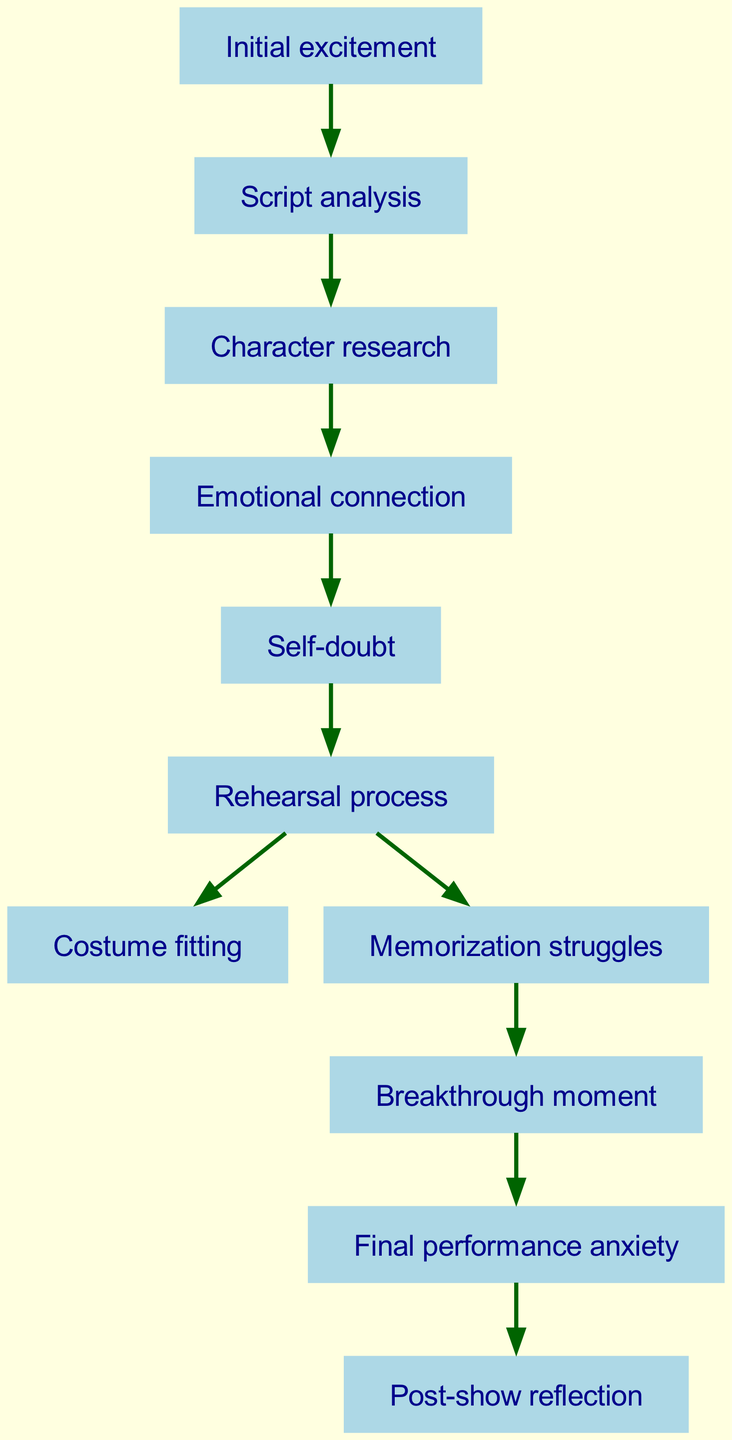What is the first step in the emotional journey? The diagram indicates that "Initial excitement" is the starting point, representing the first emotion before any preparation steps occur.
Answer: Initial excitement How many nodes are there in total? By counting the entries under the 'nodes' section in the data, a total of eleven distinct stages in the emotional journey can be identified.
Answer: 11 Which stage follows "Emotional connection"? The directed flow shows that "Self-doubt" directly follows "Emotional connection," indicating the next emotional stage after forming a connection to the character.
Answer: Self-doubt What connects "Memorization struggles" to "Breakthrough moment"? The diagram demonstrates that there is a directional edge leading from "Memorization struggles" to "Breakthrough moment," indicating that overcoming memorization issues leads to a key inspirational realization.
Answer: Breakthrough moment What is the last stage in the journey? The diagram shows that the final node in the sequence is "Post-show reflection," which concludes the emotional journey of the actor after the performance has been completed.
Answer: Post-show reflection Which node is reached after "Rehearsal process"? "Costume fitting" and "Memorization struggles" are both subsequent to "Rehearsal process," representing two parallel paths the actor can experience following rehearsals.
Answer: Costume fitting, Memorization struggles What is the emotional state reached before "Final performance anxiety"? According to the directed graph, the "Breakthrough moment" serves as the penultimate state before the actor experiences "Final performance anxiety," marking a pivotal point in preparation.
Answer: Breakthrough moment How many edges in total connect the nodes? By analyzing the 'edges' section, it's evident that there are ten distinct connections or relationships between the various emotional stages displayed in the diagram.
Answer: 10 